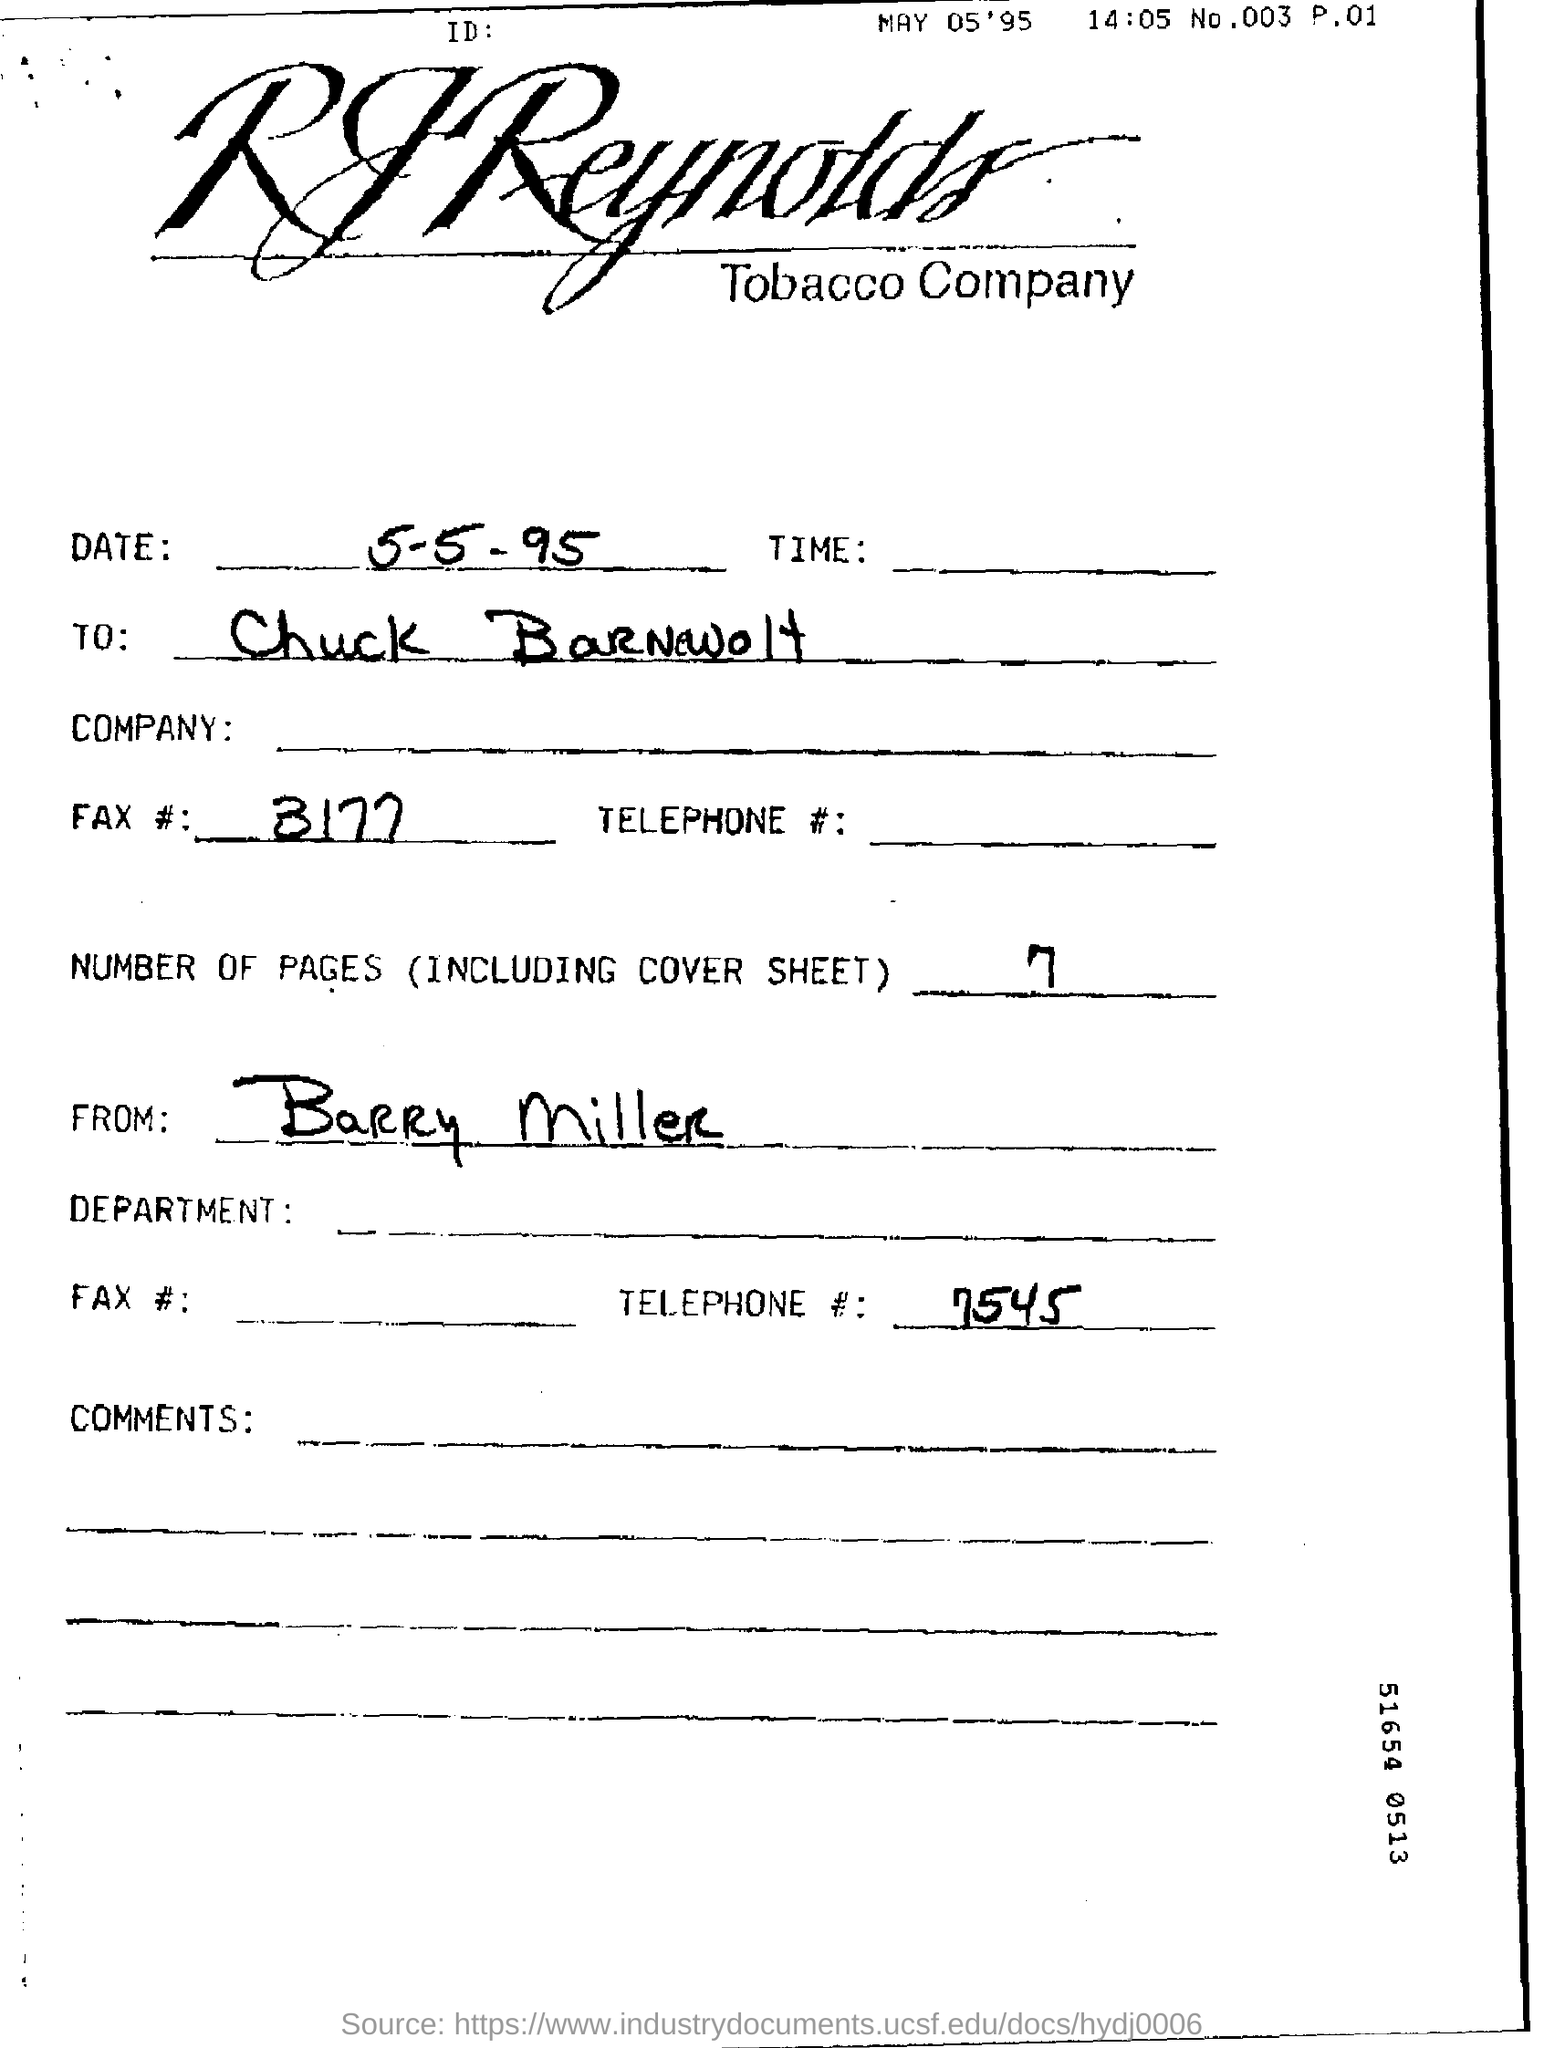Which company is mentioned in this document?
Your answer should be compact. RJ Reynolds Tobacco Company. What is the date mentioned in this document?
Your answer should be very brief. MAY 05'95. Who is the sender of the document?
Give a very brief answer. Barry Miller. How many pages are there in the document including cover sheet?
Make the answer very short. 7. What is the FAX no mentioned here?
Give a very brief answer. 3177. What is the Telephone No mentioned in this document?
Your answer should be compact. 7545. 